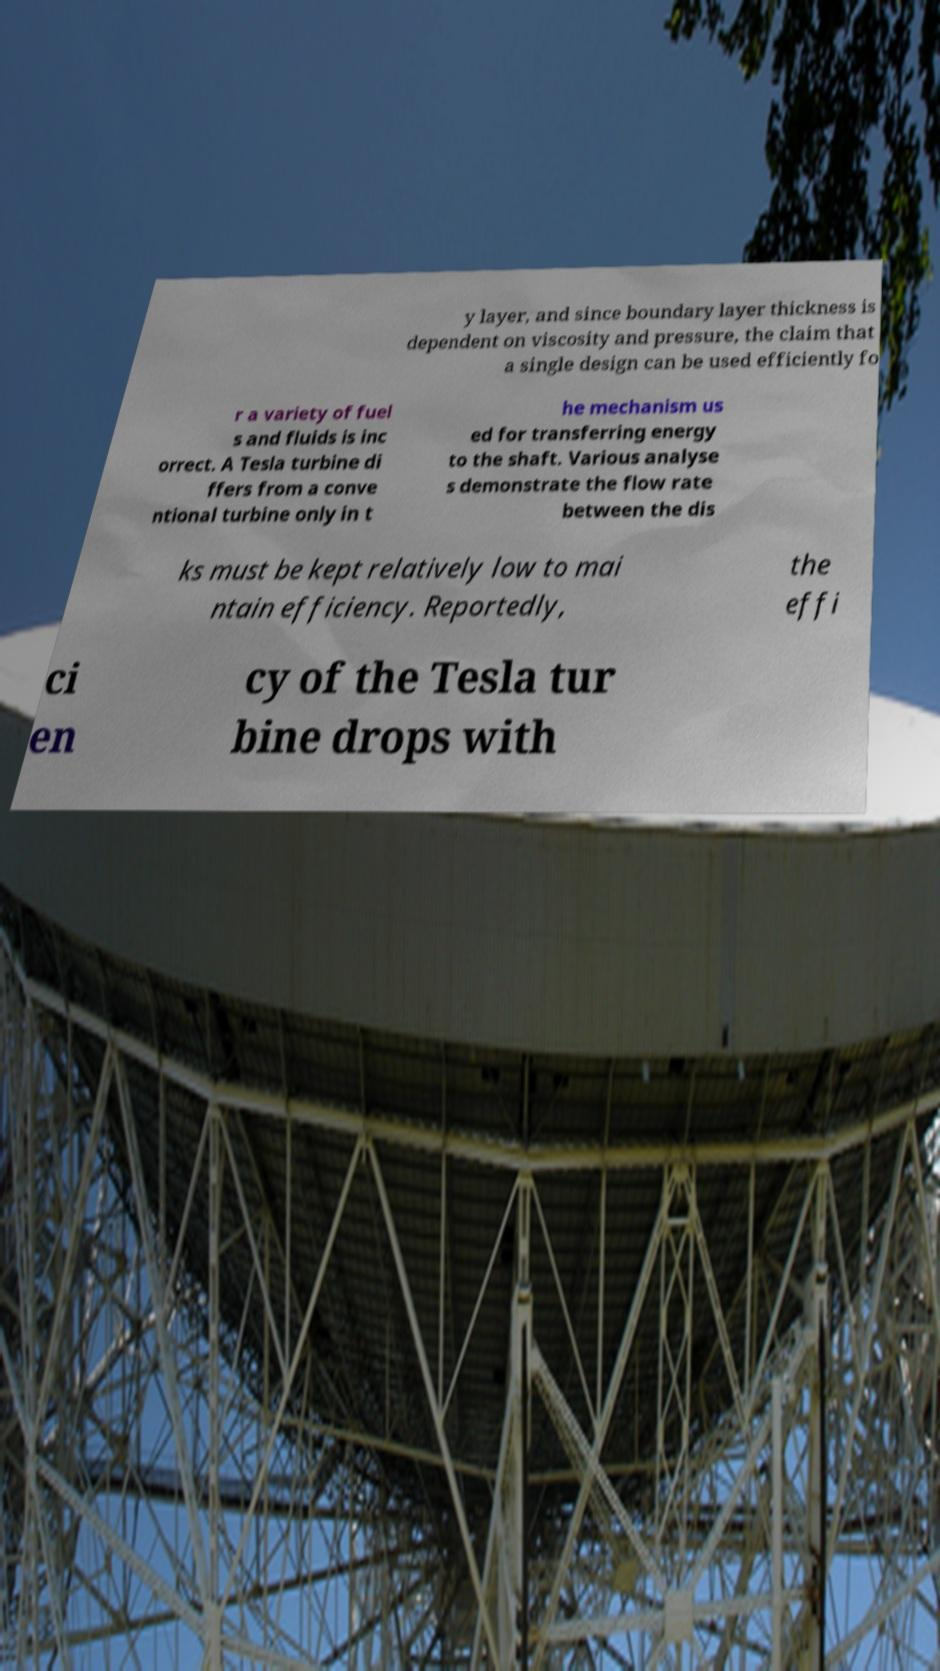Please read and relay the text visible in this image. What does it say? y layer, and since boundary layer thickness is dependent on viscosity and pressure, the claim that a single design can be used efficiently fo r a variety of fuel s and fluids is inc orrect. A Tesla turbine di ffers from a conve ntional turbine only in t he mechanism us ed for transferring energy to the shaft. Various analyse s demonstrate the flow rate between the dis ks must be kept relatively low to mai ntain efficiency. Reportedly, the effi ci en cy of the Tesla tur bine drops with 